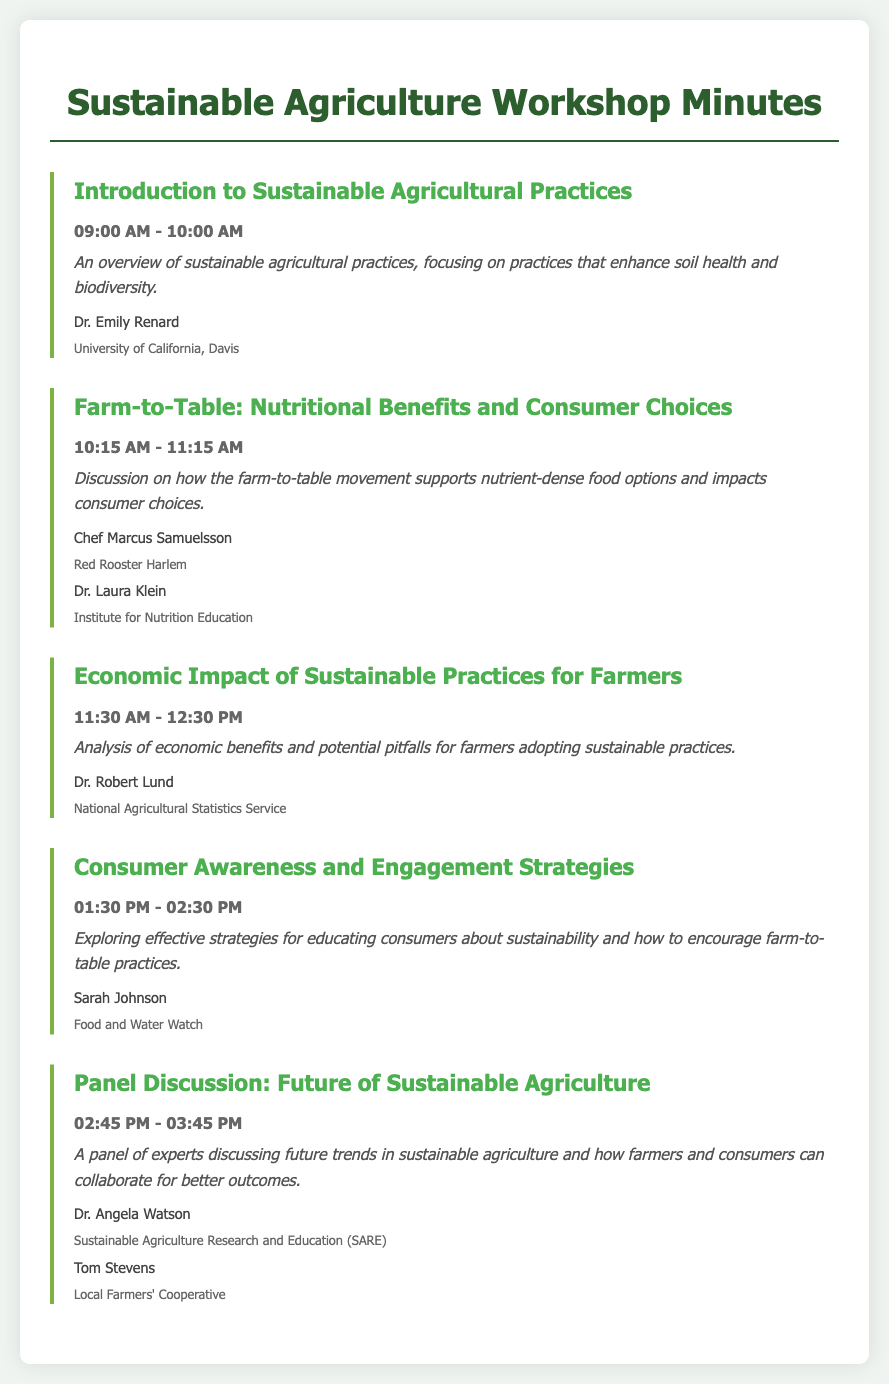What is the title of the first agenda item? The title of the first agenda item is specifically provided in the document.
Answer: Introduction to Sustainable Agricultural Practices Who is the speaker for the economic impact session? The document lists the speaker for the economic impact session, found under that agenda item.
Answer: Dr. Robert Lund What time does the consumer awareness session start? The start time for the consumer awareness session is indicated in the agenda section of the document.
Answer: 01:30 PM How many speakers are there for the farm-to-table discussion? The number of speakers for the farm-to-table discussion is specified in the section concerning that item.
Answer: 2 What is the main focus of the introduction session? The main focus of the introduction session is described in the provided description for that agenda item.
Answer: Soil health and biodiversity What is the last agenda item in the document? The last agenda item is the title provided at the end of the agenda list.
Answer: Panel Discussion: Future of Sustainable Agriculture Who is affiliated with the Local Farmers' Cooperative? The affiliation of the individual is mentioned in the documentation under the panel discussion section.
Answer: Tom Stevens What is the time duration for the sustainable practices workshop? The time slots for each session indicate the duration for the sustainable practices workshop.
Answer: 1 hour 